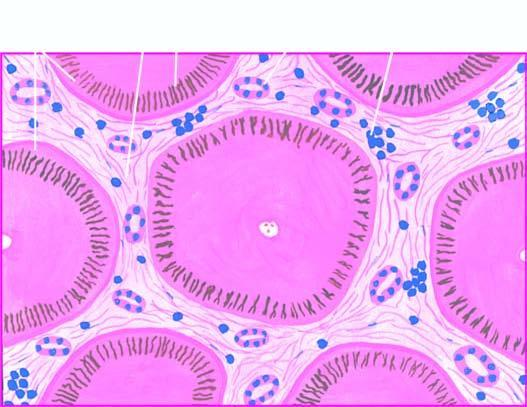re the affected area on right fibrous scars dividing the hepatic parenchyma into the micronodules?
Answer the question using a single word or phrase. No 